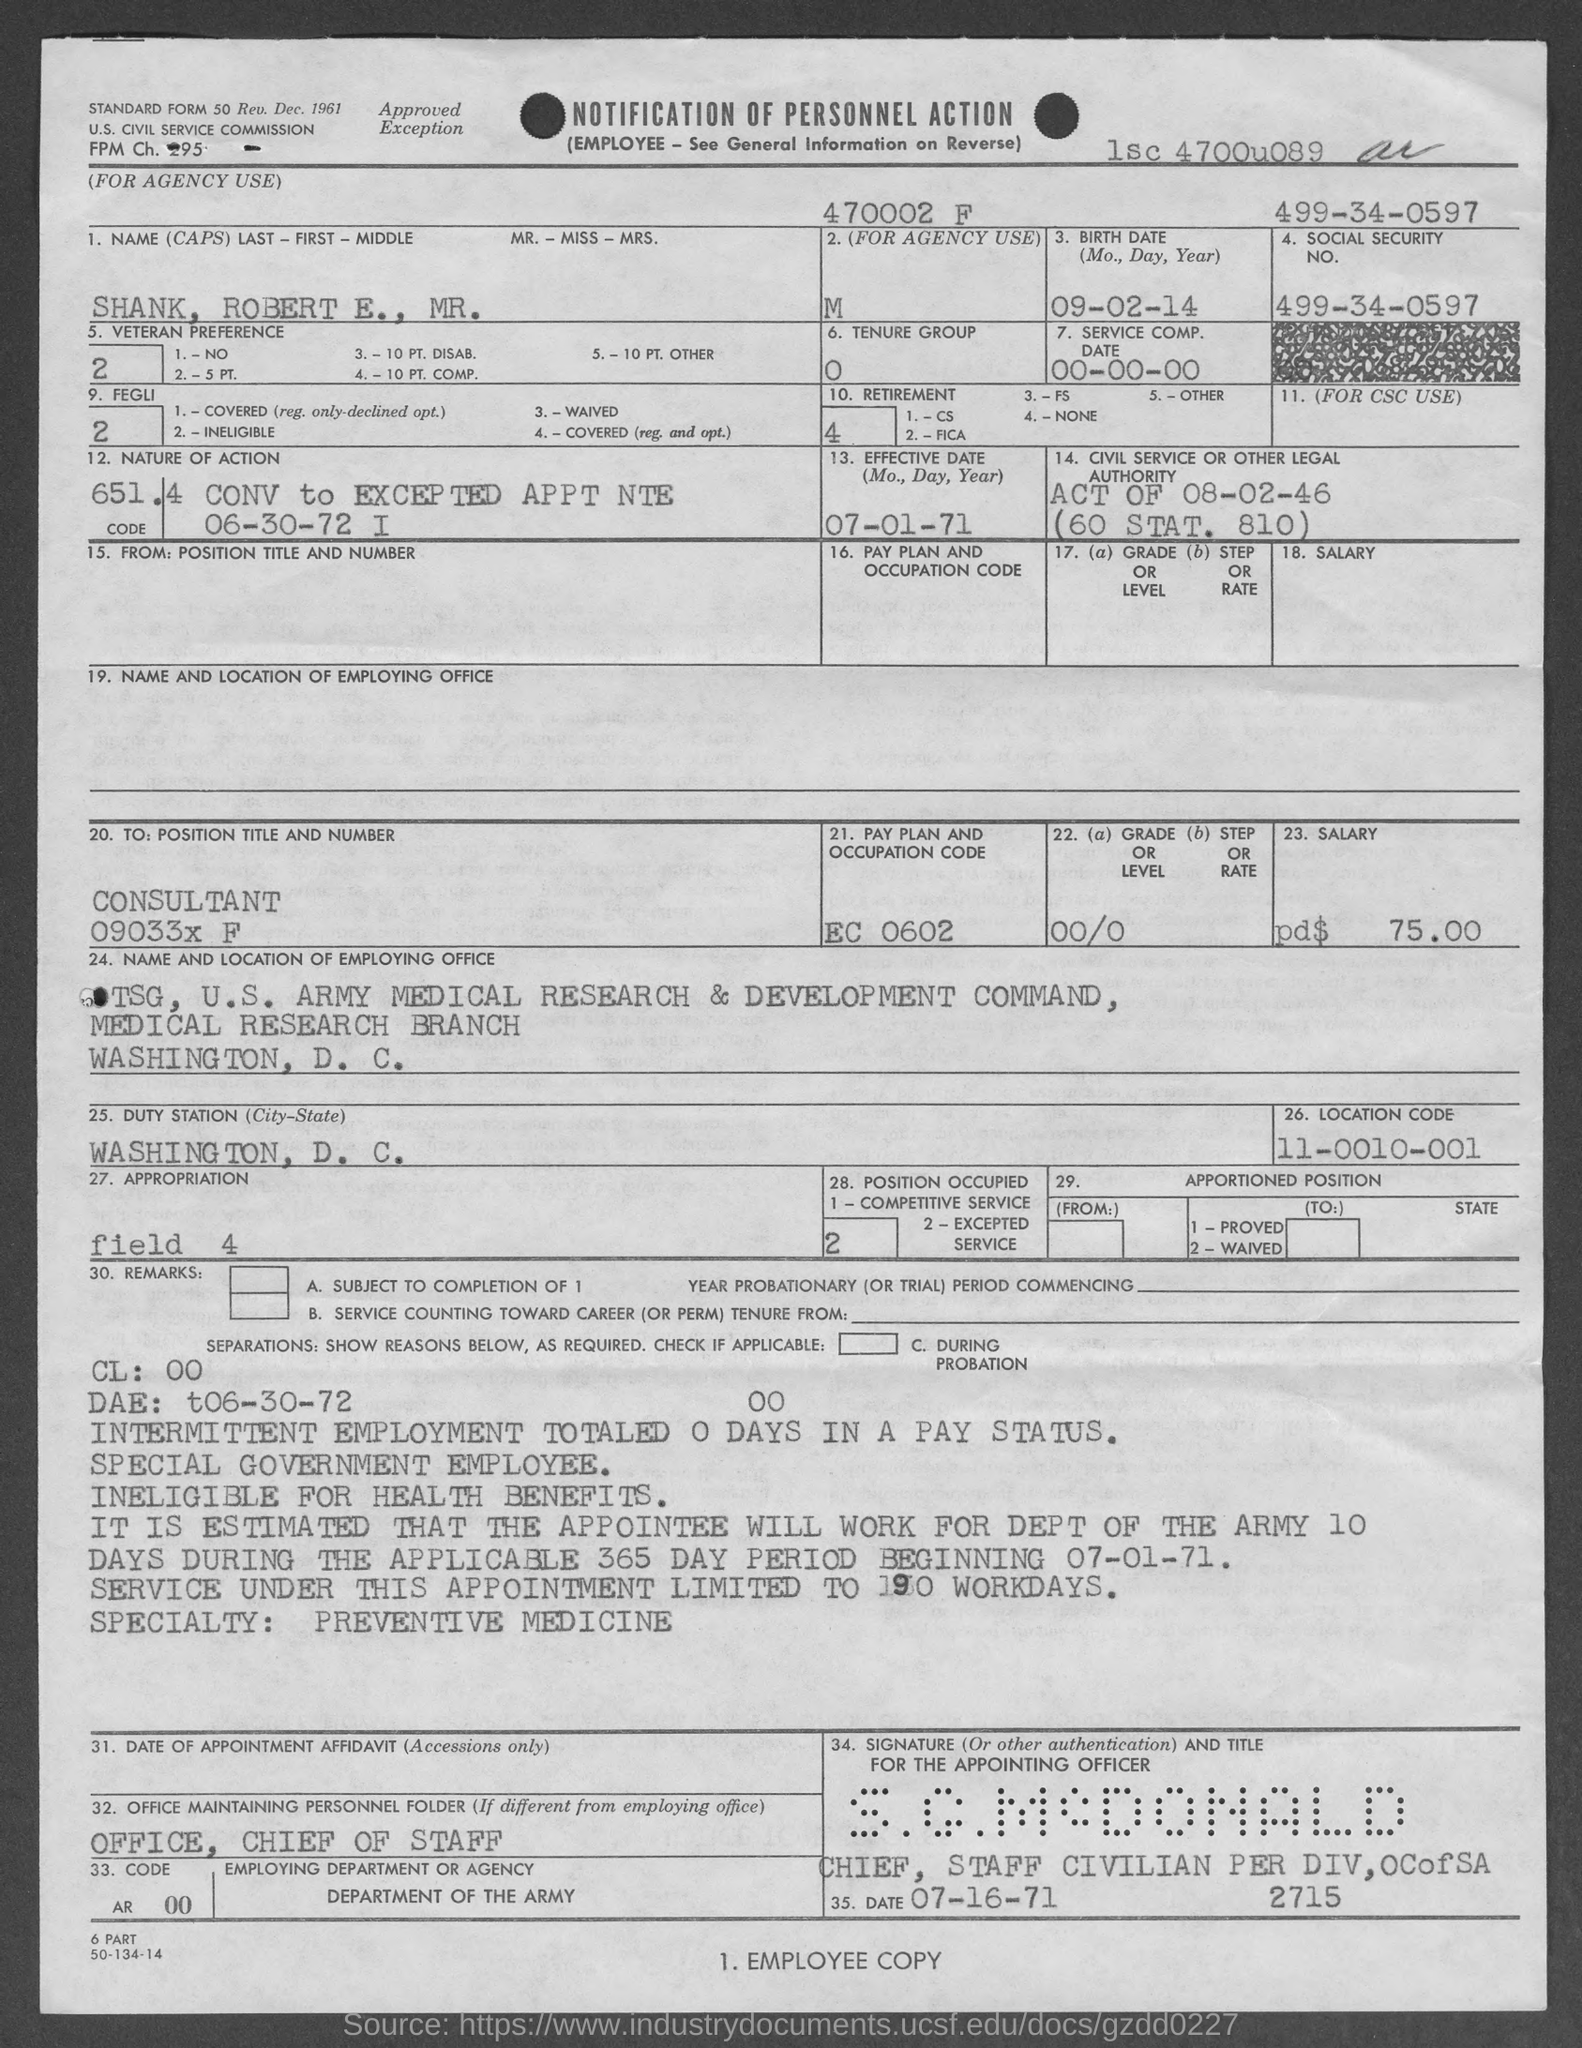What is the name given in the document?
Make the answer very short. SHANK, ROBERT E., MR. What is the birth date of Mr. Robert E. Shank?
Your answer should be very brief. 09-02-14. What is the Service Comp. date mentioned in the form?
Offer a very short reply. 00-00-00. What is the Social Security No. given in the form?
Offer a very short reply. 499-34-0597. What is the Effective Date mentioned in the form?
Offer a terse response. 07-01-71. What is the position title and number of Mr. Robert E. Shank?
Ensure brevity in your answer.  CONSULTANT 09033x F. What is the pay plan and occupation code mentioned in the form?
Your answer should be compact. EC 0602. What is the location code given in the form?
Your answer should be very brief. 11-0010-001. 